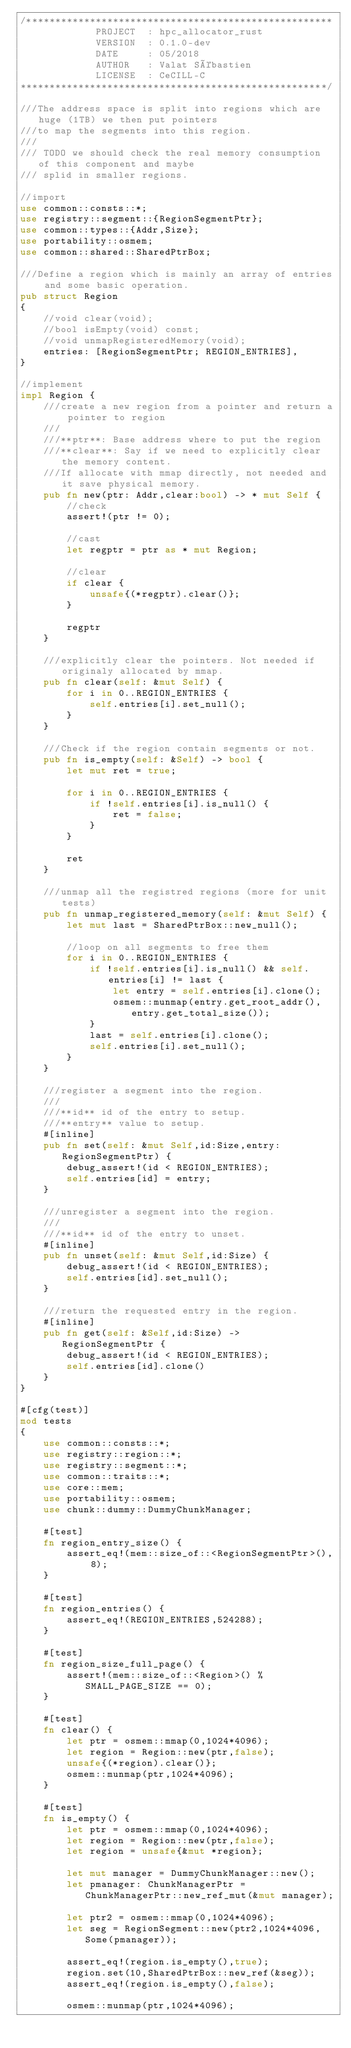Convert code to text. <code><loc_0><loc_0><loc_500><loc_500><_Rust_>/*****************************************************
             PROJECT  : hpc_allocator_rust
             VERSION  : 0.1.0-dev
             DATE     : 05/2018
             AUTHOR   : Valat Sébastien
             LICENSE  : CeCILL-C
*****************************************************/

///The address space is split into regions which are huge (1TB) we then put pointers
///to map the segments into this region.
/// 
/// TODO we should check the real memory consumption of this component and maybe
/// splid in smaller regions.

//import
use common::consts::*;
use registry::segment::{RegionSegmentPtr};
use common::types::{Addr,Size};
use portability::osmem;
use common::shared::SharedPtrBox;

///Define a region which is mainly an array of entries and some basic operation.
pub struct Region
{
	//void clear(void);
	//bool isEmpty(void) const;
	//void unmapRegisteredMemory(void);
	entries: [RegionSegmentPtr; REGION_ENTRIES],
}

//implement
impl Region {
	///create a new region from a pointer and return a pointer to region
	///
	///**ptr**: Base address where to put the region
	///**clear**: Say if we need to explicitly clear the memory content. 
	///If allocate with mmap directly, not needed and it save physical memory.
	pub fn new(ptr: Addr,clear:bool) -> * mut Self {
		//check
		assert!(ptr != 0);

		//cast
		let regptr = ptr as * mut Region;

		//clear
		if clear {
			unsafe{(*regptr).clear()};
		}

		regptr
	}

	///explicitly clear the pointers. Not needed if originaly allocated by mmap.
	pub fn clear(self: &mut Self) {
		for i in 0..REGION_ENTRIES {
			self.entries[i].set_null();
		}
	}

	///Check if the region contain segments or not.
	pub fn is_empty(self: &Self) -> bool {
		let mut ret = true;

		for i in 0..REGION_ENTRIES {
			if !self.entries[i].is_null() {
				ret = false;
			}
		}

		ret
	}

	///unmap all the registred regions (more for unit tests)
	pub fn unmap_registered_memory(self: &mut Self) {
		let mut last = SharedPtrBox::new_null();

		//loop on all segments to free them
		for i in 0..REGION_ENTRIES {
			if !self.entries[i].is_null() && self.entries[i] != last {
				let entry = self.entries[i].clone();
				osmem::munmap(entry.get_root_addr(),entry.get_total_size());
			}
			last = self.entries[i].clone();
			self.entries[i].set_null();
		}
	}

	///register a segment into the region.
	///
	///**id** id of the entry to setup.
	///**entry** value to setup.
	#[inline]
	pub fn set(self: &mut Self,id:Size,entry:RegionSegmentPtr) {
		debug_assert!(id < REGION_ENTRIES);
		self.entries[id] = entry;
	}

	///unregister a segment into the region.
	///
	///**id** id of the entry to unset.
	#[inline]
	pub fn unset(self: &mut Self,id:Size) {
		debug_assert!(id < REGION_ENTRIES);
		self.entries[id].set_null();
	}

	///return the requested entry in the region.
	#[inline]
	pub fn get(self: &Self,id:Size) -> RegionSegmentPtr {
		debug_assert!(id < REGION_ENTRIES);
		self.entries[id].clone()
	}
}

#[cfg(test)]
mod tests
{
	use common::consts::*;
	use registry::region::*;
	use registry::segment::*;
	use common::traits::*;
	use core::mem;
	use portability::osmem;
	use chunk::dummy::DummyChunkManager;

	#[test]
	fn region_entry_size() {
		assert_eq!(mem::size_of::<RegionSegmentPtr>(), 8);
	}

	#[test]
	fn region_entries() {
		assert_eq!(REGION_ENTRIES,524288);
	}

	#[test]
	fn region_size_full_page() {
		assert!(mem::size_of::<Region>() % SMALL_PAGE_SIZE == 0);
	}

	#[test]
	fn clear() {
		let ptr = osmem::mmap(0,1024*4096);
		let region = Region::new(ptr,false);
		unsafe{(*region).clear()};
		osmem::munmap(ptr,1024*4096);
	}

	#[test]
	fn is_empty() {
		let ptr = osmem::mmap(0,1024*4096);
		let region = Region::new(ptr,false);
		let region = unsafe{&mut *region};

		let mut manager = DummyChunkManager::new();
		let pmanager: ChunkManagerPtr = ChunkManagerPtr::new_ref_mut(&mut manager);

		let ptr2 = osmem::mmap(0,1024*4096);
		let seg = RegionSegment::new(ptr2,1024*4096,Some(pmanager));
		
		assert_eq!(region.is_empty(),true);
		region.set(10,SharedPtrBox::new_ref(&seg));
		assert_eq!(region.is_empty(),false);
		
		osmem::munmap(ptr,1024*4096);</code> 